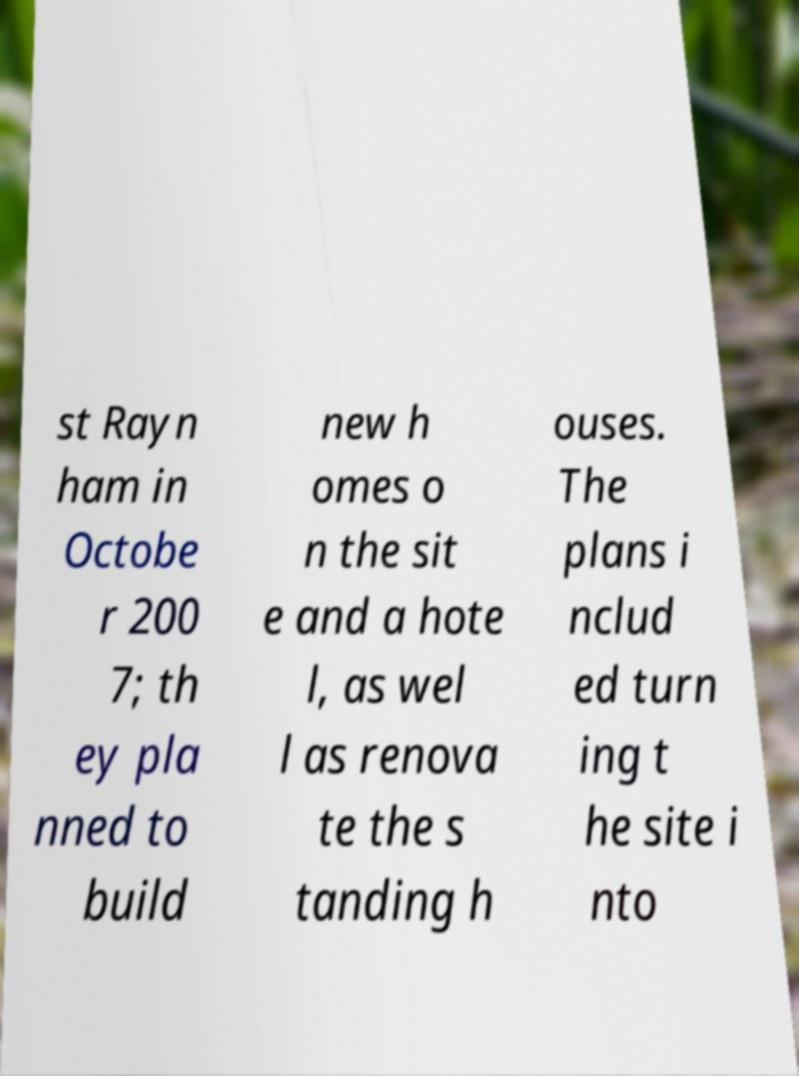Could you extract and type out the text from this image? st Rayn ham in Octobe r 200 7; th ey pla nned to build new h omes o n the sit e and a hote l, as wel l as renova te the s tanding h ouses. The plans i nclud ed turn ing t he site i nto 